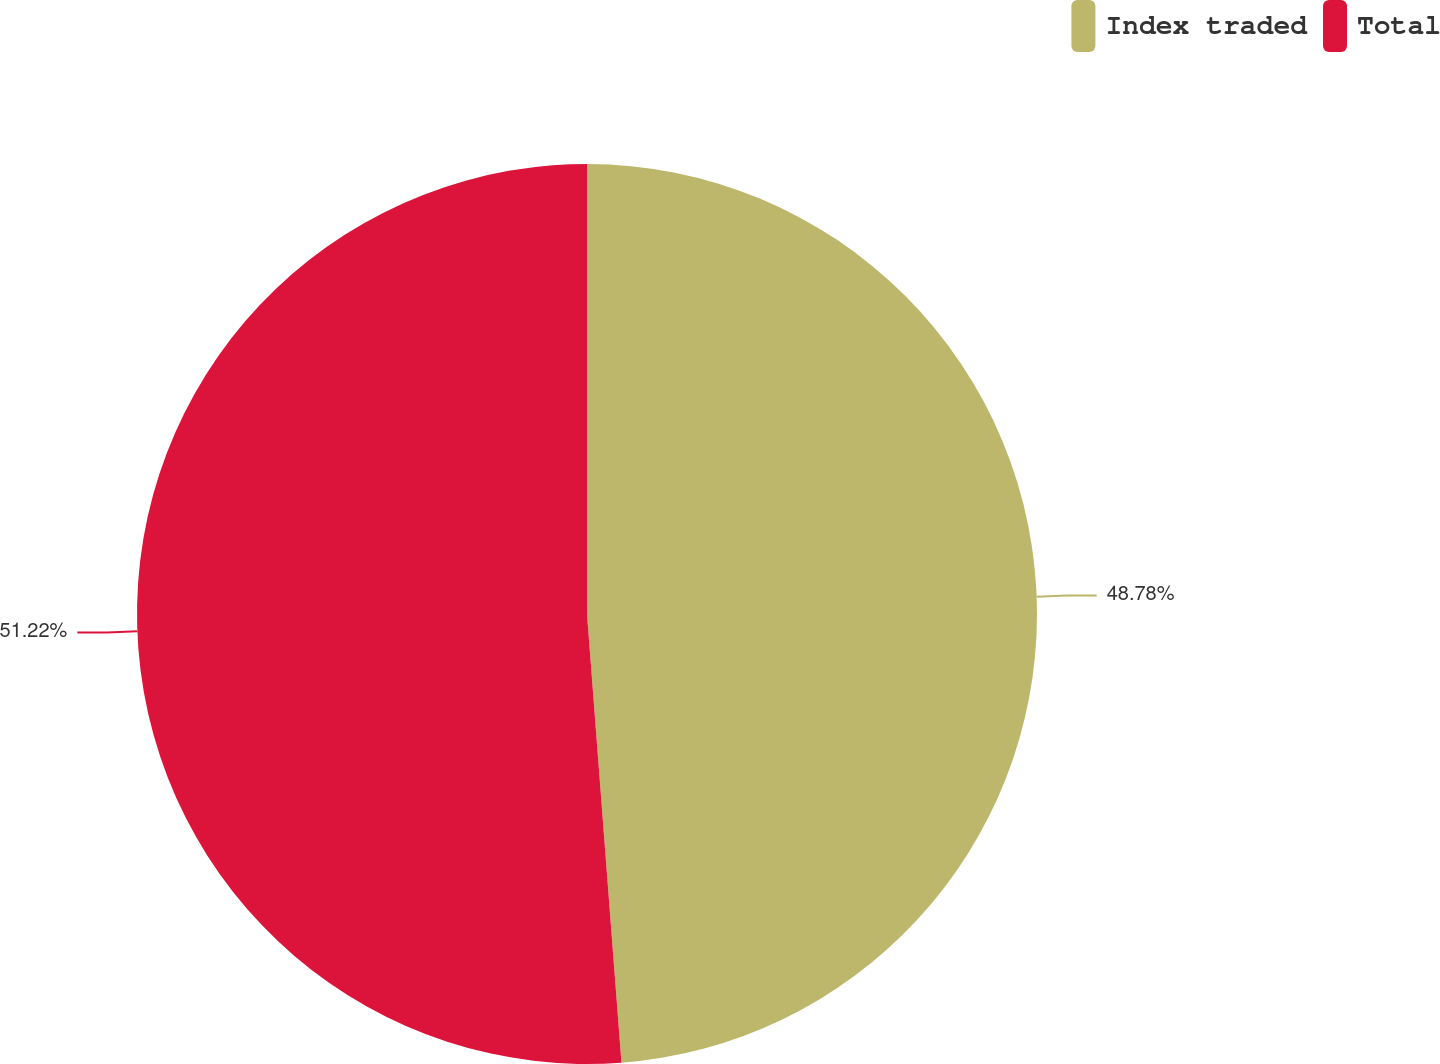Convert chart to OTSL. <chart><loc_0><loc_0><loc_500><loc_500><pie_chart><fcel>Index traded<fcel>Total<nl><fcel>48.78%<fcel>51.22%<nl></chart> 